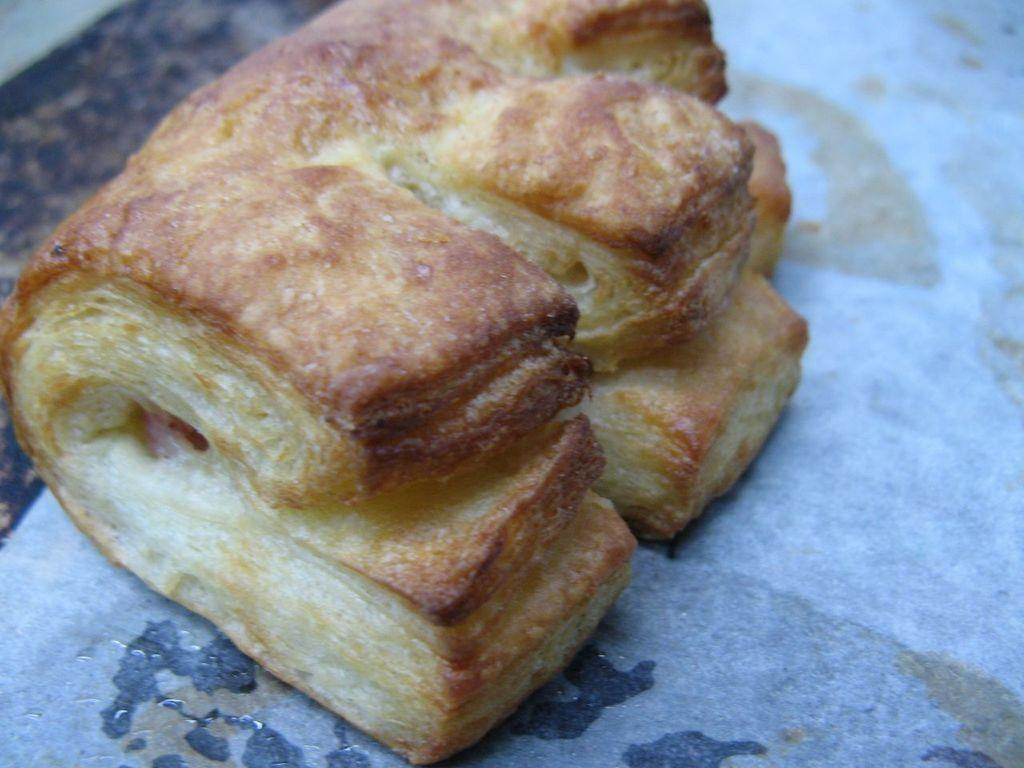What type of food is present in the image? There is a croissant in the image. What is the name of the friend who is downtown in the image? There is no friend or downtown location present in the image; it only features a croissant. 